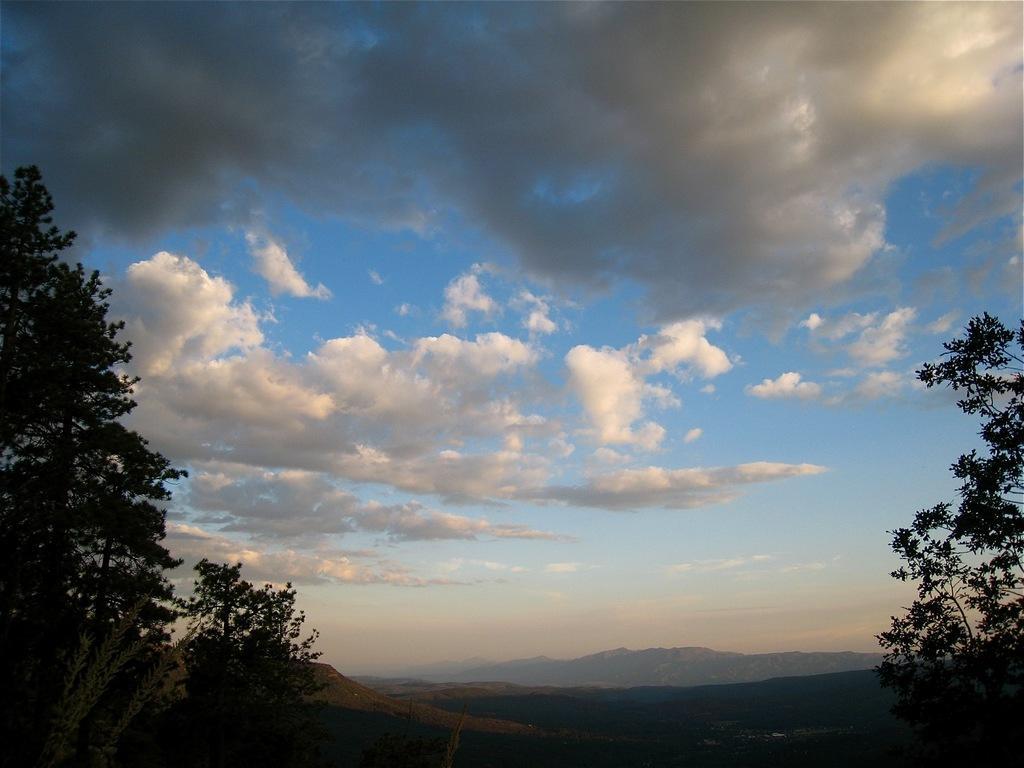Could you give a brief overview of what you see in this image? In this picture we can see can sky and clouds. In the background we can see many mountains. Here we can see trees and plants. 